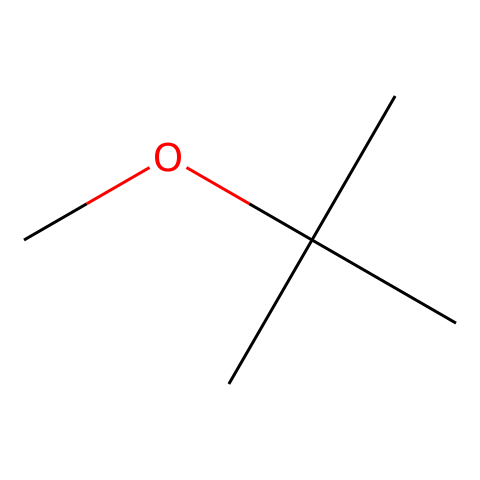how many carbon atoms are in this molecule? The SMILES representation shows a methyl group (CH3) and a tert-butyl group (C(C)(C)C), which together consist of four carbons from the tert-butyl and one carbon from the methyl group. Thus, there are five carbon atoms in total.
Answer: five what is the functional group presented in this structure? The structure contains an ether functional group, characterized by the oxygen atom connected to two carbon-containing groups (in this case, the methyl and tert-butyl groups). This is typical for ethers.
Answer: ether how many hydrogen atoms are attached to the carbon backbone? Evaluating the structure, each of the four carbon atoms in the tert-butyl group is connected to three hydrogen atoms, and the methyl group contributes three hydrogens. Altogether, the tert-butyl contributes 9 and the methyl contributes 3, giving a total of 12 hydrogen atoms.
Answer: twelve what is the molecular formula of methyl tert-butyl ether? Counting the previously discussed carbon, hydrogen, and oxygen atoms, we have five carbon atoms (C), twelve hydrogen atoms (H), and one oxygen atom (O). Therefore, the molecular formula is C5H12O.
Answer: C5H12O does this compound contain any double bonds? Analyzing the structure, there are no double bonds present between any of the carbon atoms or between carbon and oxygen; all bonds are single. This confirms that it is a fully saturated molecule without any unsaturation.
Answer: no why is methyl tert-butyl ether used as a gasoline additive? Methyl tert-butyl ether is utilized as a gasoline additive primarily to enhance octane ratings and reduce engine knocking. The branched structure of tert-butyl helps improve combustion efficiency.
Answer: octane boost what type of intermolecular forces are likely present in this compound? Given the presence of polar C-O bonds, methyl tert-butyl ether will experience dipole-dipole interactions and van der Waals forces due to its size and shape. Therefore, this molecule can engage in intermolecular hydrogen bonding as well, although it's more limited.
Answer: dipole-dipole, van der Waals 